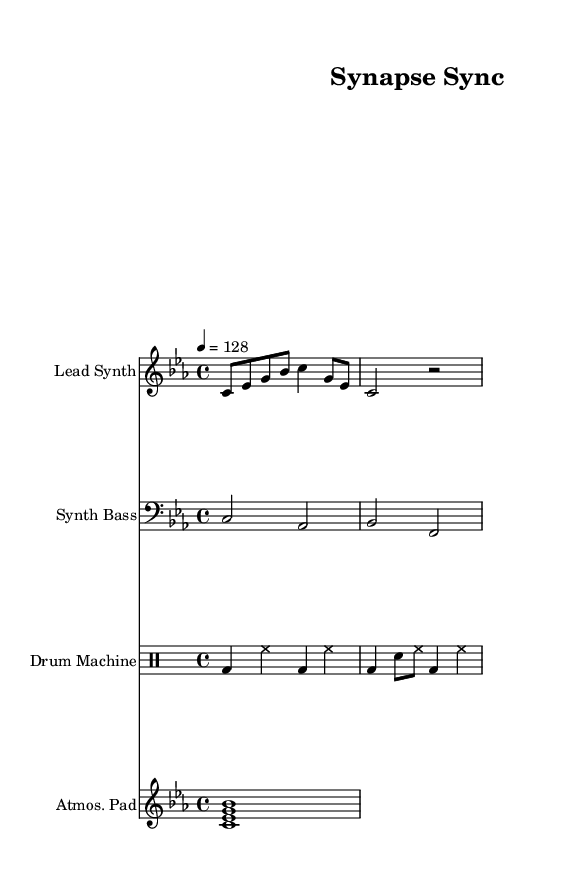What is the key signature of this music? The key signature is C minor, which contains three flats: B flat, E flat, and A flat. This information can be identified from the key indication at the beginning of the score.
Answer: C minor What is the time signature of this music? The time signature is 4/4, indicated at the beginning of the score. This means there are four beats in each measure and a quarter note receives one beat.
Answer: 4/4 What is the tempo marking in beats per minute? The tempo marking is specified as 128 beats per minute, which is shown directly in the score under the tempo indication, leading to a moderate pace for the piece.
Answer: 128 How many measures does the lead synth part have? The lead synth part consists of two measures, which can be counted by looking at the number of vertical bar lines separating the different sections of music.
Answer: 2 measures What type of instrument is specified for the third staff? The third staff is labeled as "Drum Machine," indicating it is meant for percussion sounds created by a drum machine, typical in electronic music genres.
Answer: Drum Machine How many different instrumental parts are present in the score? There are four instrumental parts listed in the score: Lead Synth, Synth Bass, Drum Machine, and Atmospheric Pad, identifiable from the separate staves and their labels.
Answer: 4 What chord is played in the atmospheric pad? The atmospheric pad plays the chord C minor (C, E flat, G) as indicated by the notes in the chord played on the staff, which includes C, E flat, and G.
Answer: C minor 